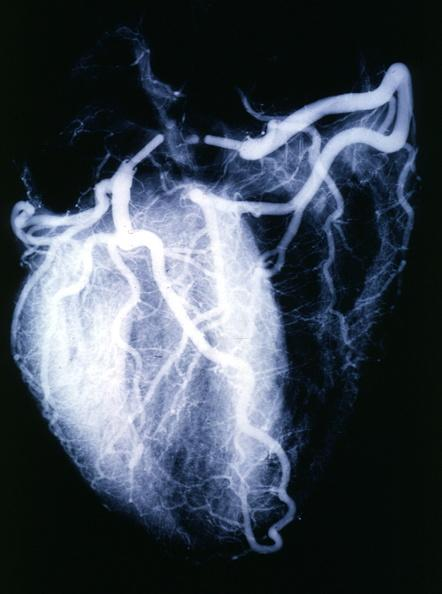s angiogram present?
Answer the question using a single word or phrase. Yes 